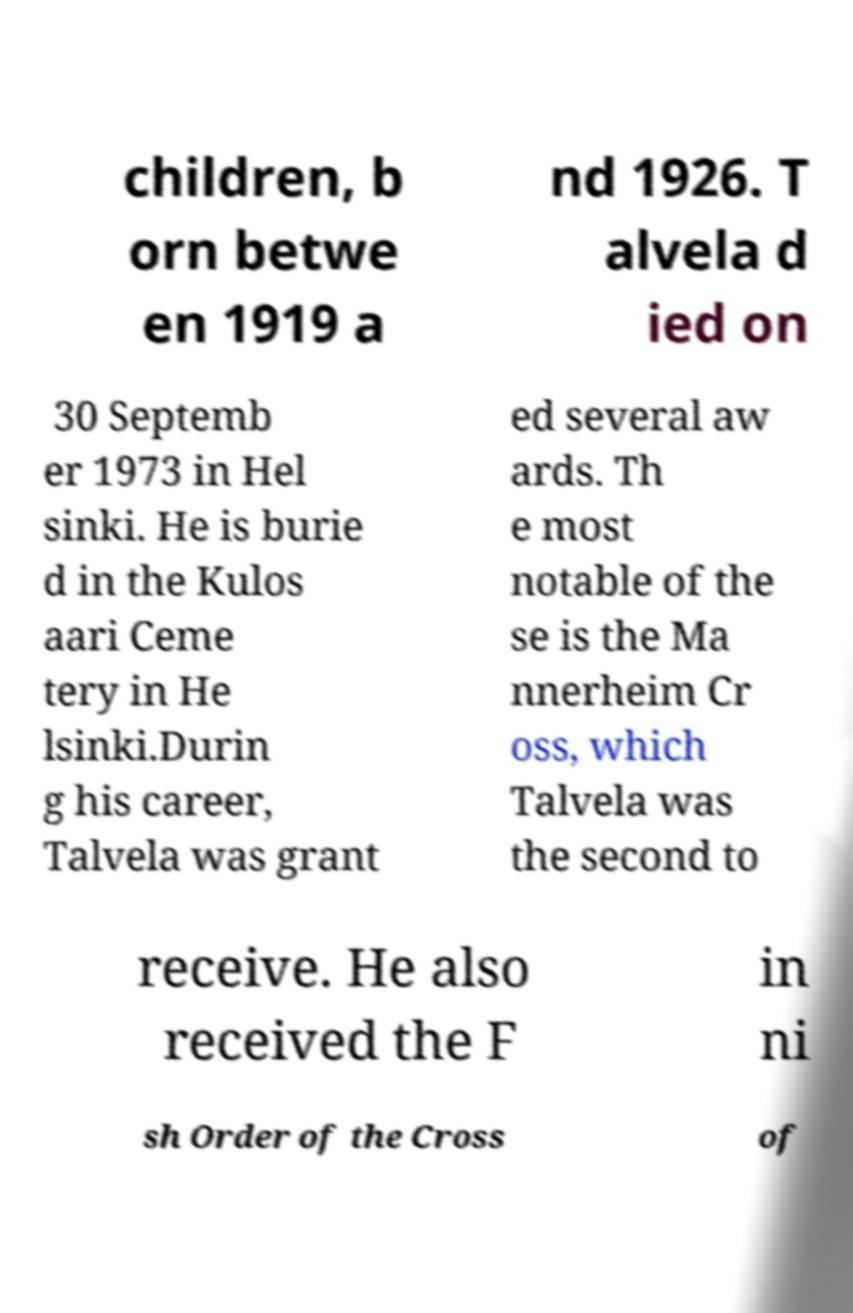Can you accurately transcribe the text from the provided image for me? children, b orn betwe en 1919 a nd 1926. T alvela d ied on 30 Septemb er 1973 in Hel sinki. He is burie d in the Kulos aari Ceme tery in He lsinki.Durin g his career, Talvela was grant ed several aw ards. Th e most notable of the se is the Ma nnerheim Cr oss, which Talvela was the second to receive. He also received the F in ni sh Order of the Cross of 